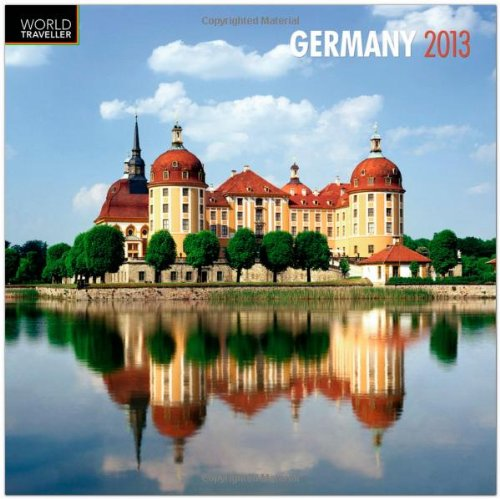Which year's calendar is this? The calendar features images and dates for the year 2013, as clearly highlighted in its title. 